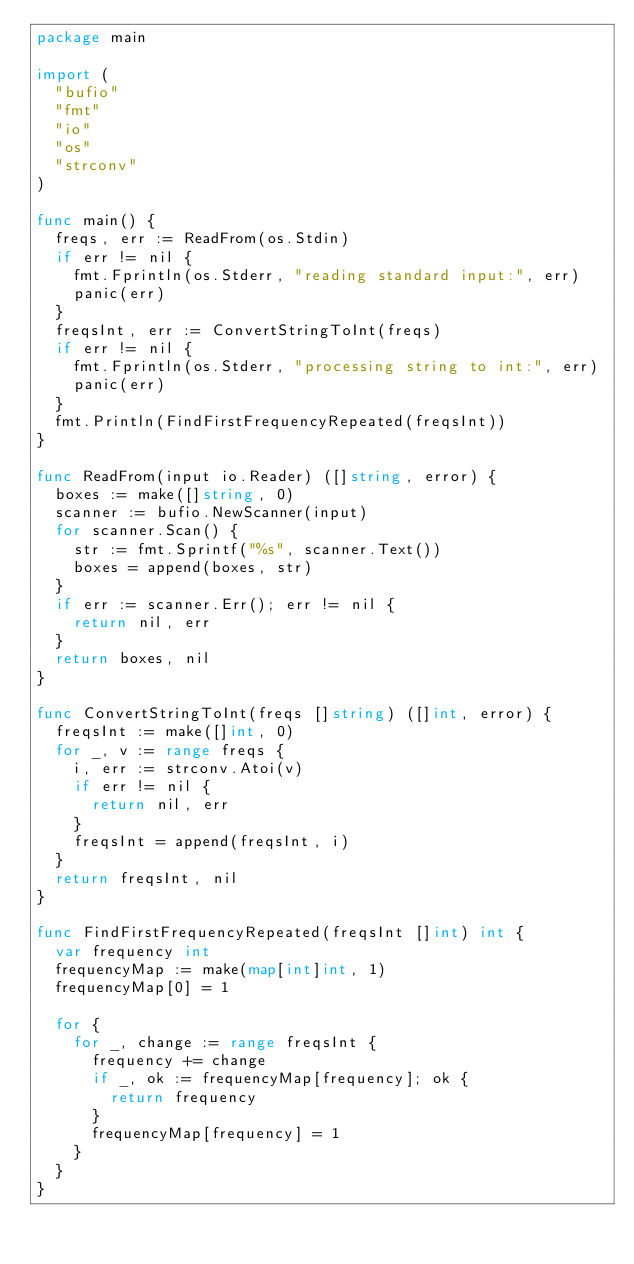<code> <loc_0><loc_0><loc_500><loc_500><_Go_>package main

import (
	"bufio"
	"fmt"
	"io"
	"os"
	"strconv"
)

func main() {
	freqs, err := ReadFrom(os.Stdin)
	if err != nil {
		fmt.Fprintln(os.Stderr, "reading standard input:", err)
		panic(err)
	}
	freqsInt, err := ConvertStringToInt(freqs)
	if err != nil {
		fmt.Fprintln(os.Stderr, "processing string to int:", err)
		panic(err)
	}
	fmt.Println(FindFirstFrequencyRepeated(freqsInt))
}

func ReadFrom(input io.Reader) ([]string, error) {
	boxes := make([]string, 0)
	scanner := bufio.NewScanner(input)
	for scanner.Scan() {
		str := fmt.Sprintf("%s", scanner.Text())
		boxes = append(boxes, str)
	}
	if err := scanner.Err(); err != nil {
		return nil, err
	}
	return boxes, nil
}

func ConvertStringToInt(freqs []string) ([]int, error) {
	freqsInt := make([]int, 0)
	for _, v := range freqs {
		i, err := strconv.Atoi(v)
		if err != nil {
			return nil, err
		}
		freqsInt = append(freqsInt, i)
	}
	return freqsInt, nil
}

func FindFirstFrequencyRepeated(freqsInt []int) int {
	var frequency int
	frequencyMap := make(map[int]int, 1)
	frequencyMap[0] = 1

	for {
		for _, change := range freqsInt {
			frequency += change
			if _, ok := frequencyMap[frequency]; ok {
				return frequency
			}
			frequencyMap[frequency] = 1
		}
	}
}
</code> 